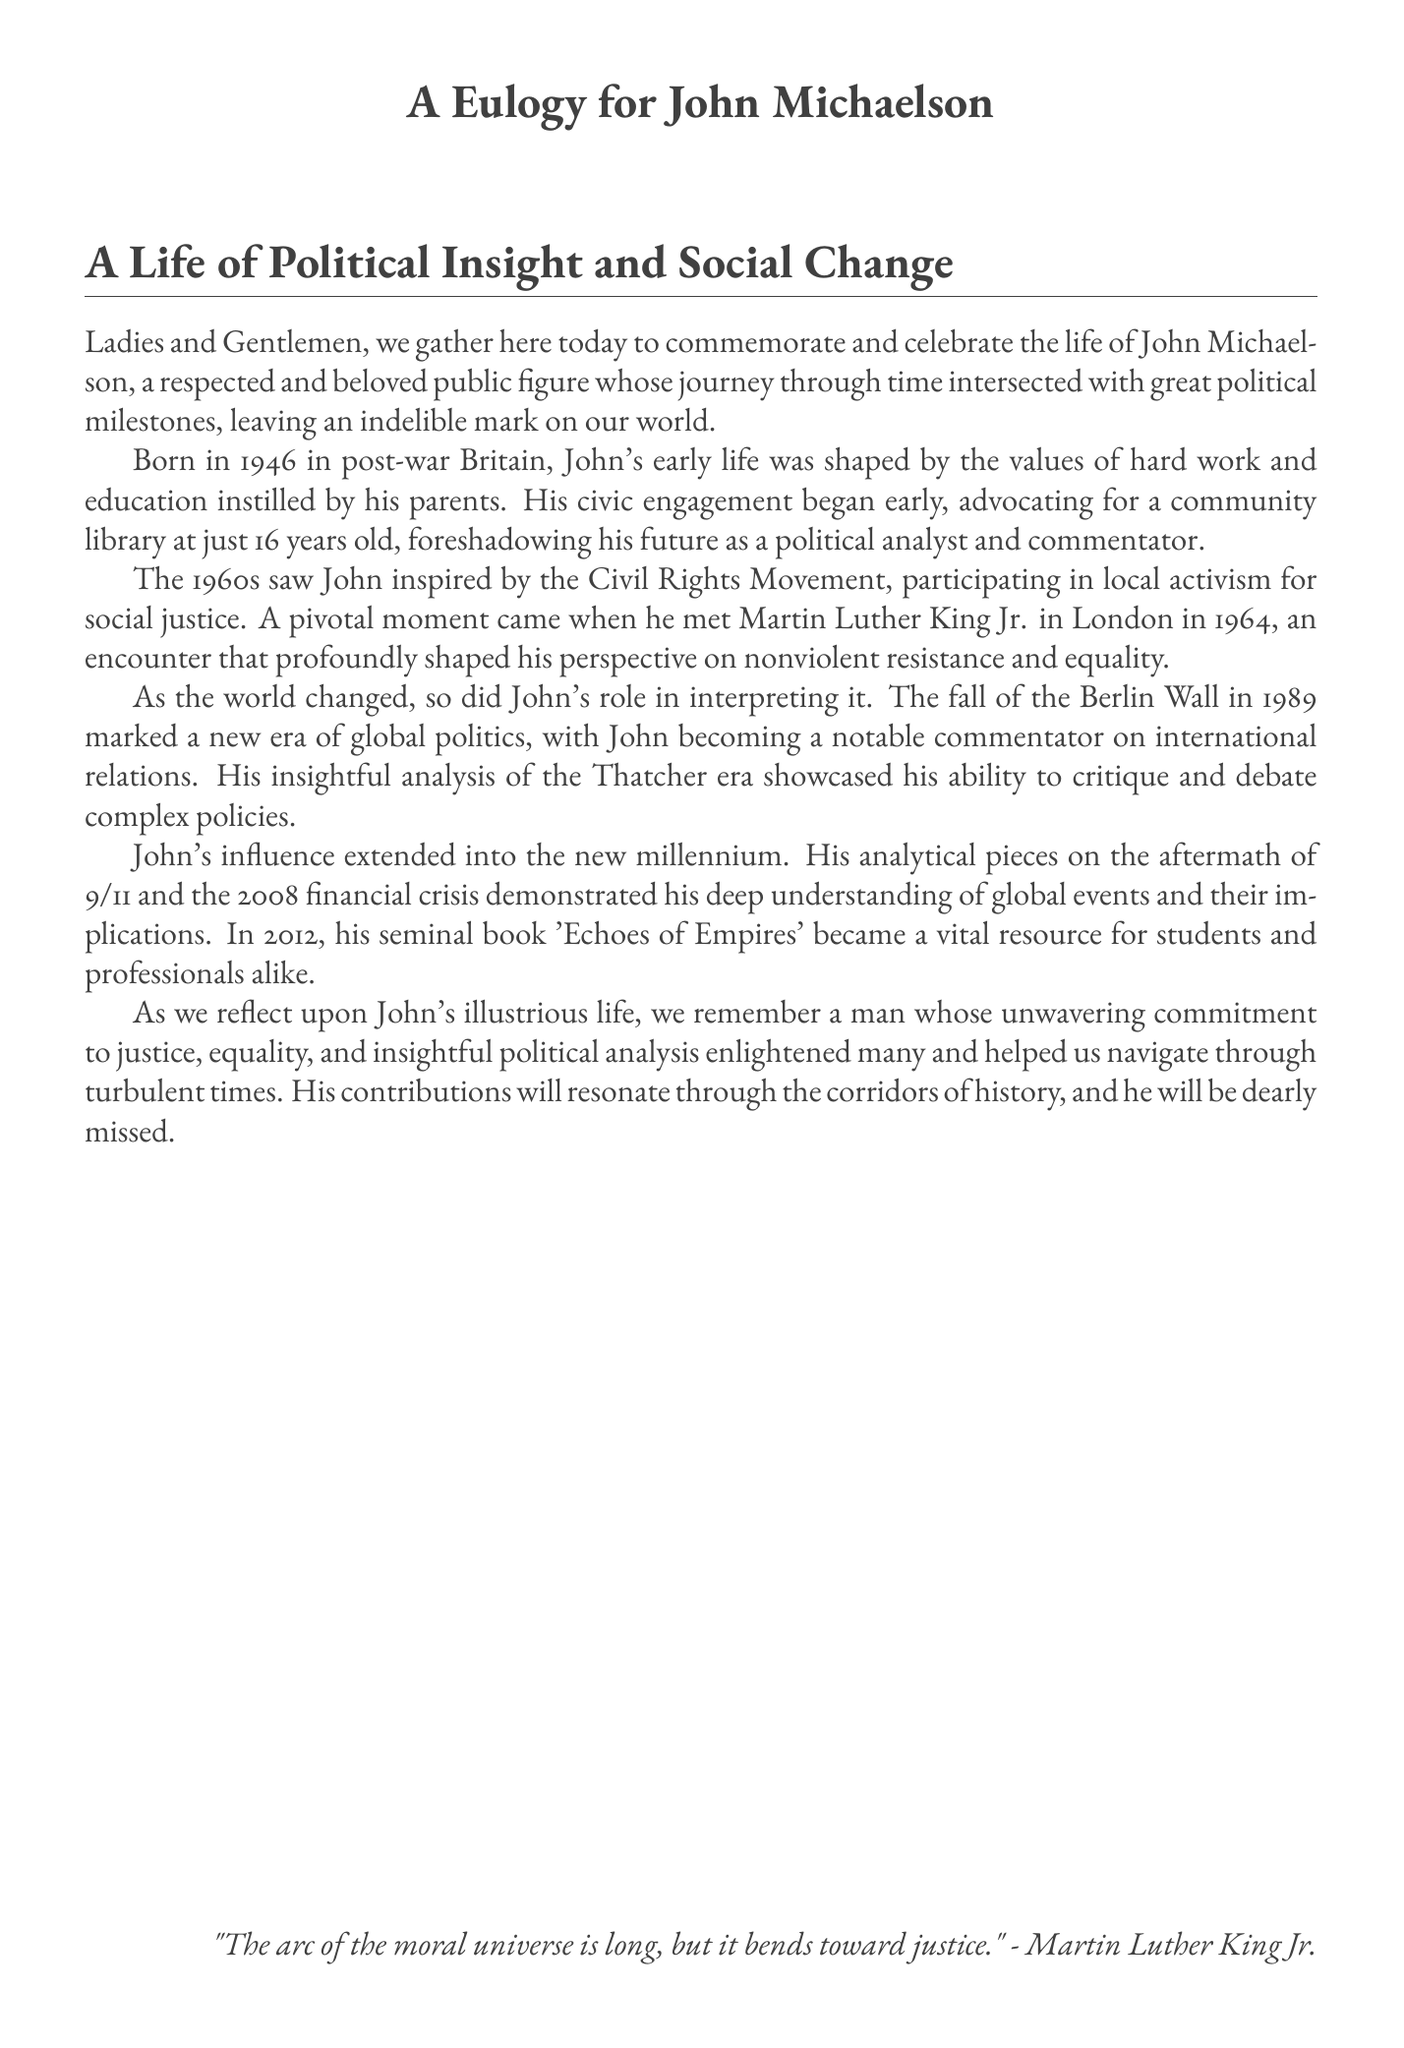What year was John Michaelson born? The document states that John Michaelson was born in 1946.
Answer: 1946 What significant event did John witness in 1989? The document mentions the fall of the Berlin Wall as a significant event in 1989.
Answer: Fall of the Berlin Wall What was the title of John’s seminal book published in 2012? The document refers to his book titled 'Echoes of Empires' published in 2012.
Answer: Echoes of Empires At what age did John advocate for a community library? The document states that he advocated for a community library at the age of 16.
Answer: 16 Who did John meet in London that influenced his views on nonviolent resistance? The document mentions that John met Martin Luther King Jr. in 1964.
Answer: Martin Luther King Jr What major global event did John analyze after 9/11? The document states that John analyzed the aftermath of 9/11 as a major event.
Answer: Aftermath of 9/11 Which political era did John critique according to the document? The document mentions John's critique of the Thatcher era.
Answer: Thatcher era What is the main theme highlighted in John’s contributions? The document emphasizes his commitment to justice and equality.
Answer: Justice and equality What quote is included at the end of the eulogy? The document includes a quote by Martin Luther King Jr. regarding the moral universe.
Answer: "The arc of the moral universe is long, but it bends toward justice." 